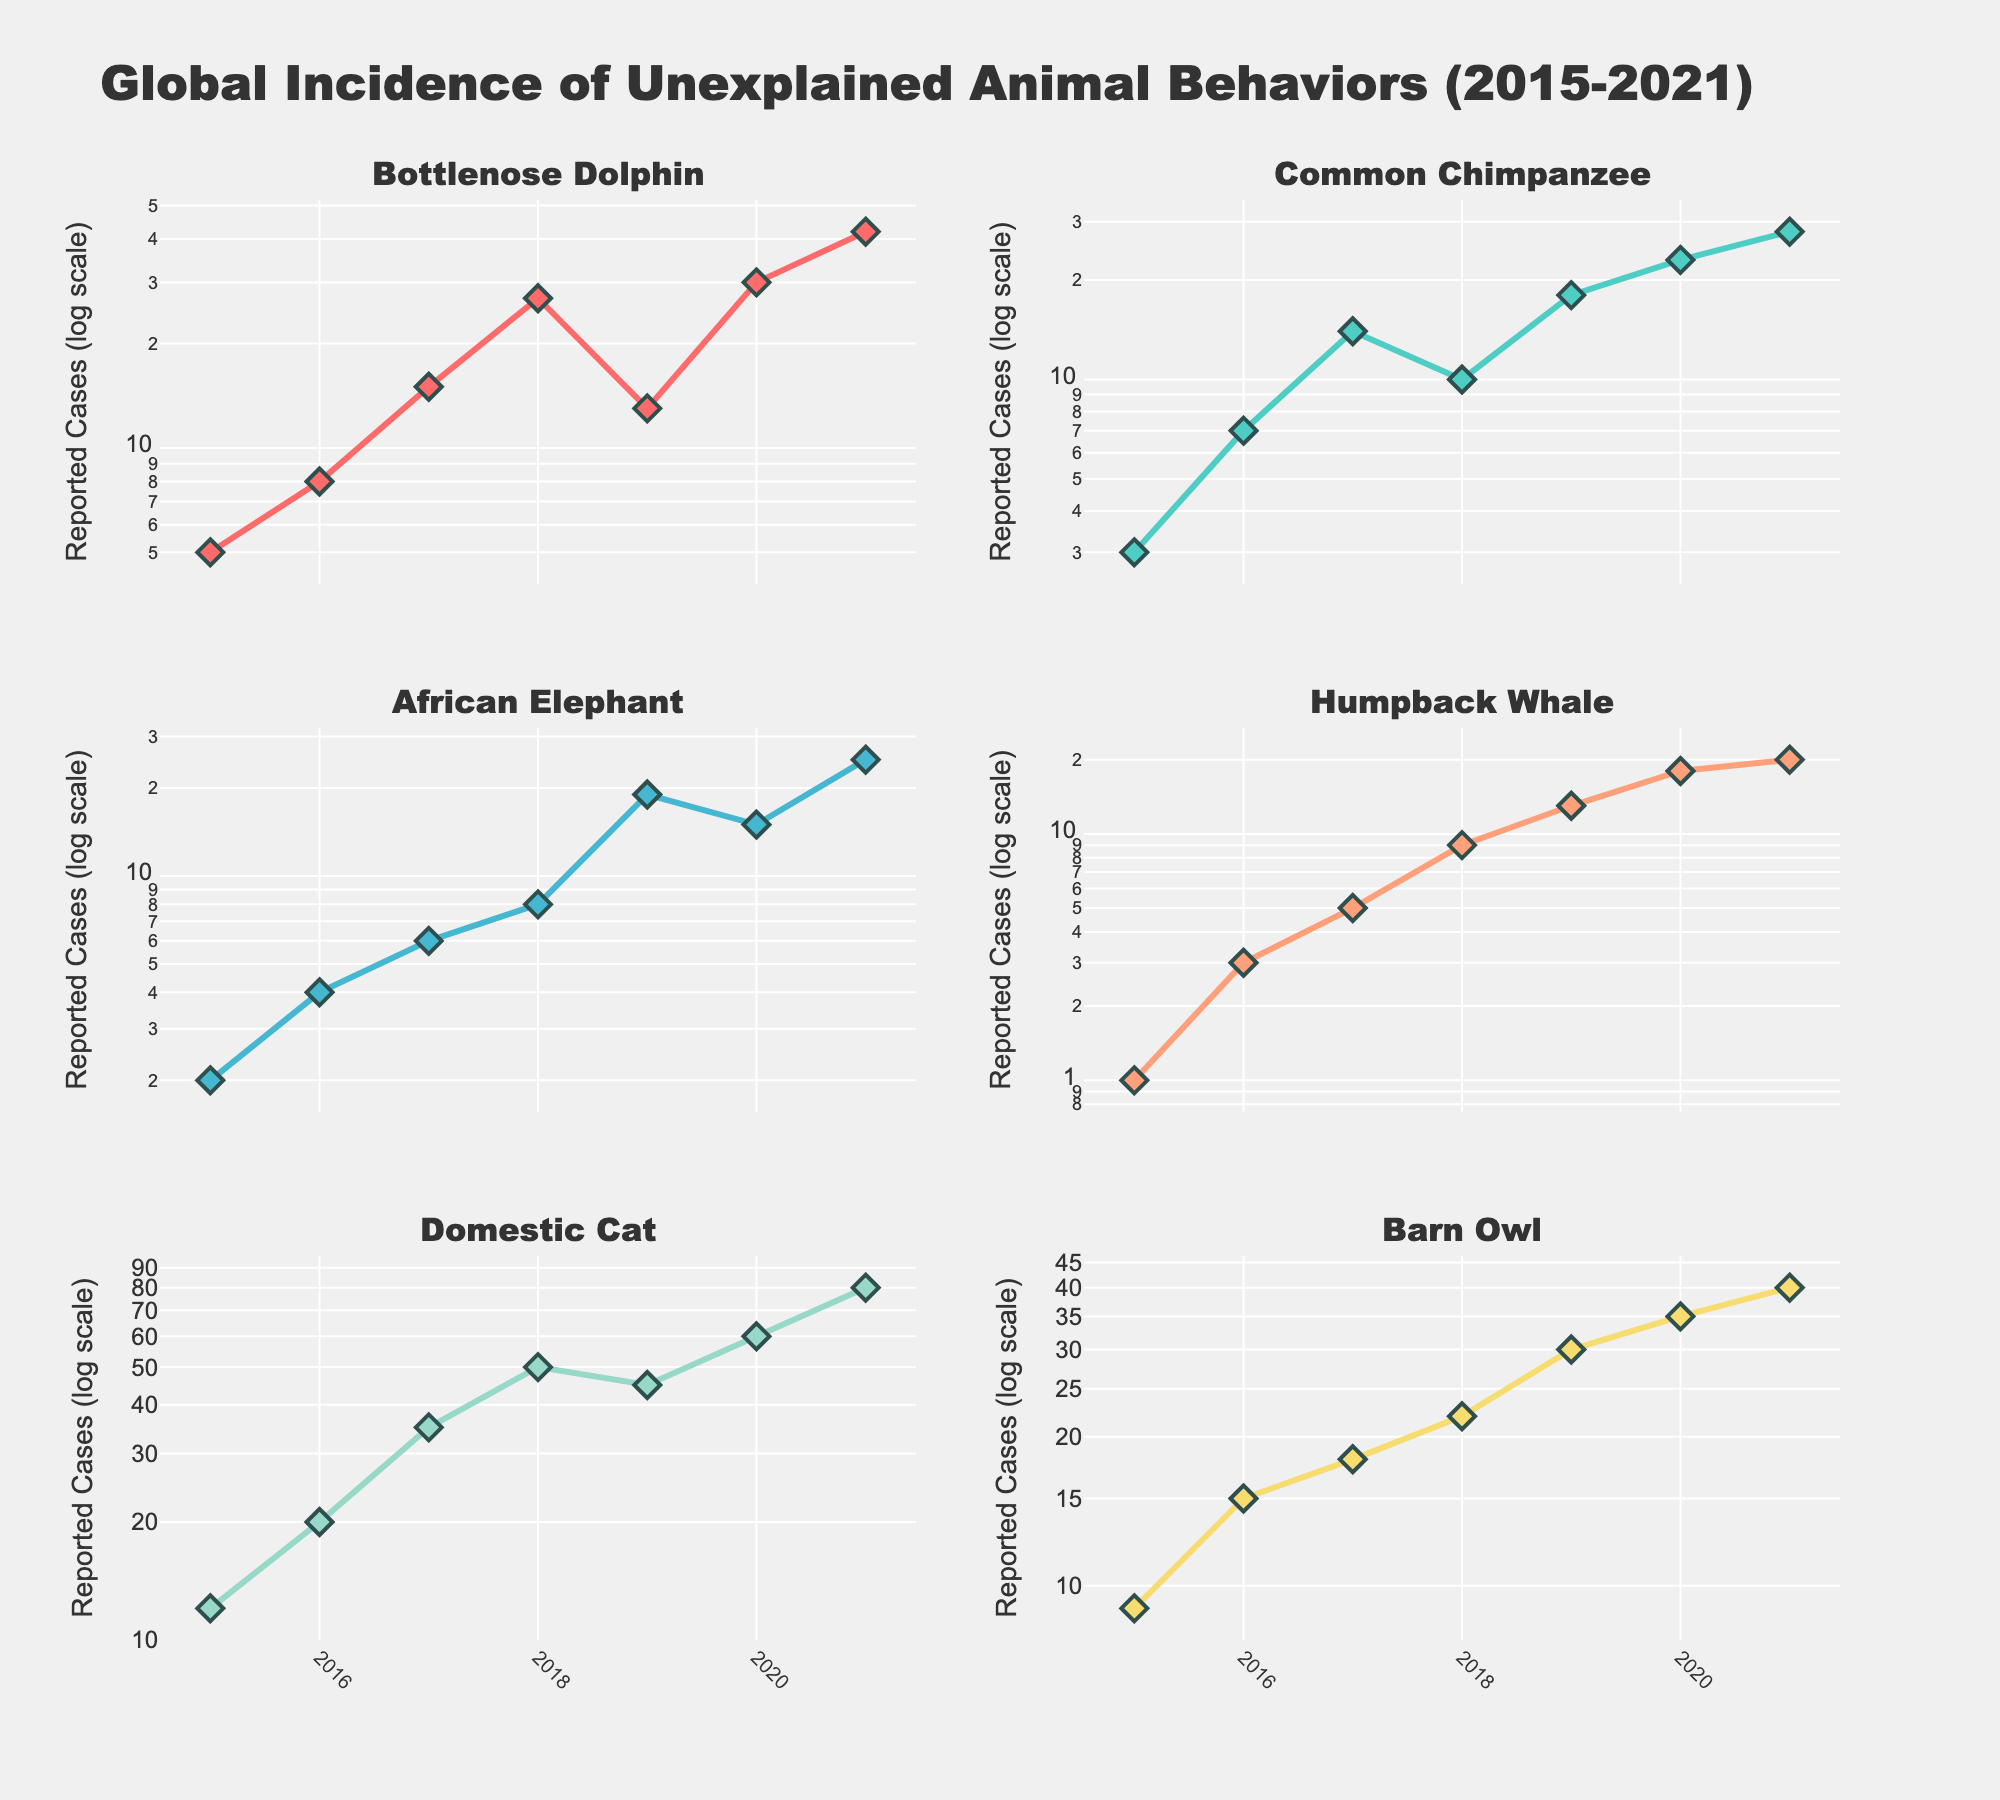How many species are included in the figure? The figure contains subplots with different titles, each representing a unique species. By counting these titles, we determine the number of species visualized.
Answer: 6 What is the general trend for reported cases in Bottlenose Dolphins from 2015 to 2021? To identify the trend, observe the points plotted for Bottlenose Dolphins and draw a mental line through them. Increasing values over time indicate an upward trend, while decreasing values indicate a downward trend. The visual shows an increasing trend overall despite some fluctuations.
Answer: Increasing Which species had the highest number of reported cases in 2021? By observing and comparing the data points for each species in the year 2021, we identify the species with the highest y-value.
Answer: Domestic Cat How many reported cases were there for the African Elephant in 2019? Locate the subplot for African Elephant and find the data point corresponding to 2019. The y-value of this point, read off the logarithmic scale, gives the number of reported cases.
Answer: 19 Which species showed the most significant increase in reported cases between 2015 and 2021? To determine this, compare the difference in reported cases for each species from 2015 to 2021. The species with the largest difference has the most significant increase.
Answer: Domestic Cat In which years did the Bottlenose Dolphin report more than 20 cases? Focus on the subplot for Bottlenose Dolphins and identify years where the y-values (log-scaled) exceed 20.
Answer: 2018, 2020, 2021 Compare the trend in reported cases of the Common Chimpanzee and Humpback Whale between 2015 and 2021. Examine the subplots for both species, identifying if their trends (increase, decrease, or stability) are similar or different over the years. The trend shows data points for both species increasing over time.
Answer: Similar increasing trend What is the compound annual growth rate (CAGR) of reported cases for the Domestic Cat if it increased from 12 in 2015 to 80 in 2021? The formula for CAGR is ((Ending value/Beginning value)^(1/Number of periods))-1. Thus, ((80/12)^(1/6))-1. Perform the calculation to find CAGR.
Answer: 0.351 (or 35.1%) Do you notice any unusual peaks or drops in reported cases for any species? If yes, which species and in what year? By examining the subplots, spikes, or sudden drops in individual species curves can be identified. For instance, Bottlenose Dolphins have a spike in 2020, going up from 13 in 2019 to 30.
Answer: Bottlenose Dolphin, 2020 Which species shows a nearly linear increase on the log scale, indicating exponential growth? A nearly linear pattern on a log scale indicates exponential growth. Identify the species whose subplot exhibits a straight-line pattern.
Answer: Domestic Cat 